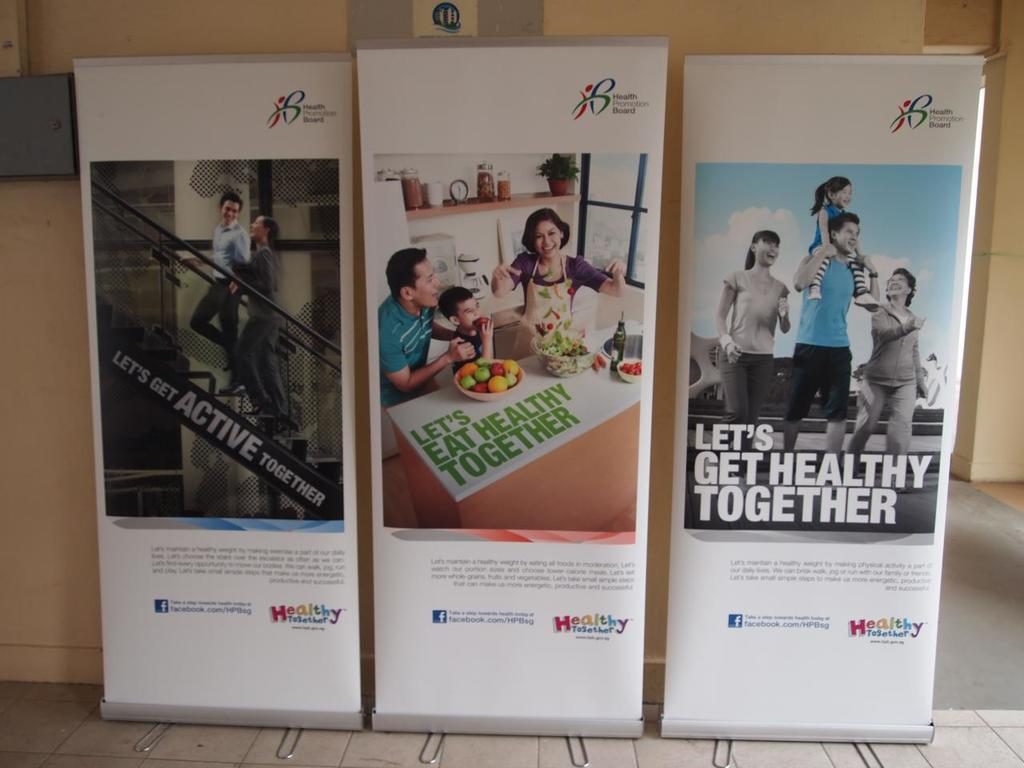<image>
Present a compact description of the photo's key features. the phrase let's get healthy together is on a poster 